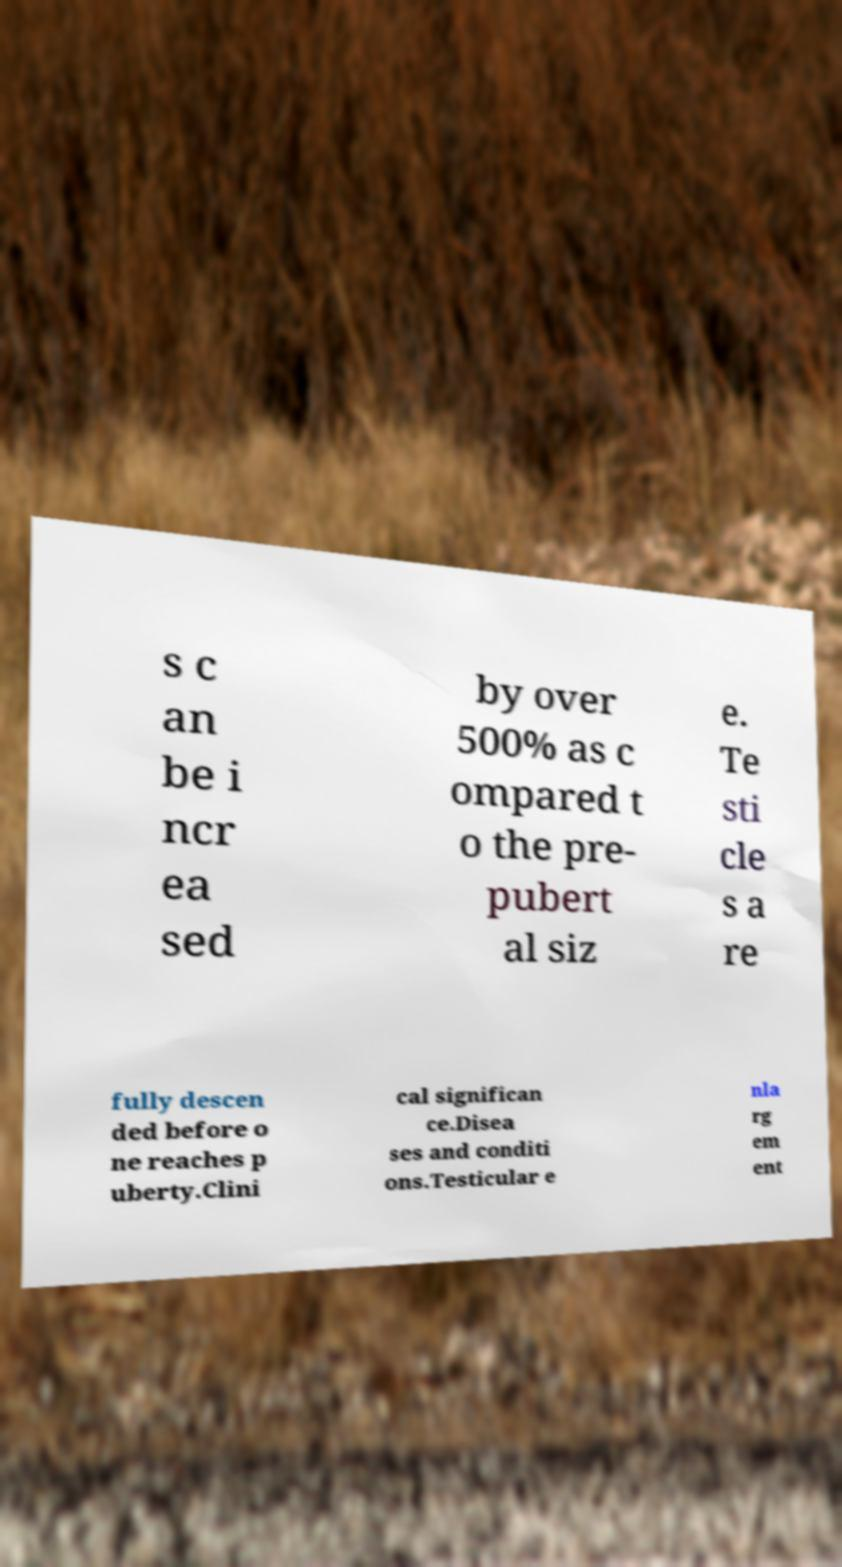Can you read and provide the text displayed in the image?This photo seems to have some interesting text. Can you extract and type it out for me? s c an be i ncr ea sed by over 500% as c ompared t o the pre- pubert al siz e. Te sti cle s a re fully descen ded before o ne reaches p uberty.Clini cal significan ce.Disea ses and conditi ons.Testicular e nla rg em ent 